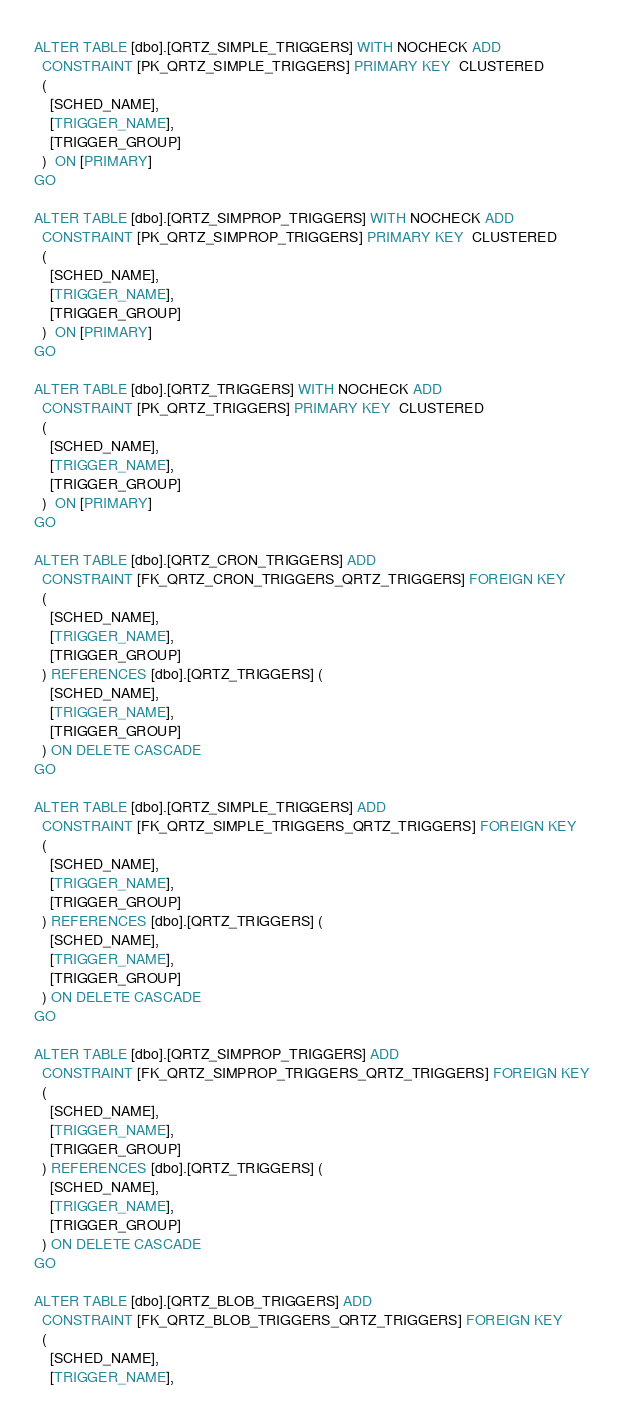Convert code to text. <code><loc_0><loc_0><loc_500><loc_500><_SQL_>
ALTER TABLE [dbo].[QRTZ_SIMPLE_TRIGGERS] WITH NOCHECK ADD
  CONSTRAINT [PK_QRTZ_SIMPLE_TRIGGERS] PRIMARY KEY  CLUSTERED
  (
    [SCHED_NAME],
    [TRIGGER_NAME],
    [TRIGGER_GROUP]
  )  ON [PRIMARY]
GO

ALTER TABLE [dbo].[QRTZ_SIMPROP_TRIGGERS] WITH NOCHECK ADD
  CONSTRAINT [PK_QRTZ_SIMPROP_TRIGGERS] PRIMARY KEY  CLUSTERED
  (
    [SCHED_NAME],
    [TRIGGER_NAME],
    [TRIGGER_GROUP]
  )  ON [PRIMARY]
GO

ALTER TABLE [dbo].[QRTZ_TRIGGERS] WITH NOCHECK ADD
  CONSTRAINT [PK_QRTZ_TRIGGERS] PRIMARY KEY  CLUSTERED
  (
    [SCHED_NAME],
    [TRIGGER_NAME],
    [TRIGGER_GROUP]
  )  ON [PRIMARY]
GO

ALTER TABLE [dbo].[QRTZ_CRON_TRIGGERS] ADD
  CONSTRAINT [FK_QRTZ_CRON_TRIGGERS_QRTZ_TRIGGERS] FOREIGN KEY
  (
    [SCHED_NAME],
    [TRIGGER_NAME],
    [TRIGGER_GROUP]
  ) REFERENCES [dbo].[QRTZ_TRIGGERS] (
    [SCHED_NAME],
    [TRIGGER_NAME],
    [TRIGGER_GROUP]
  ) ON DELETE CASCADE
GO

ALTER TABLE [dbo].[QRTZ_SIMPLE_TRIGGERS] ADD
  CONSTRAINT [FK_QRTZ_SIMPLE_TRIGGERS_QRTZ_TRIGGERS] FOREIGN KEY
  (
    [SCHED_NAME],
    [TRIGGER_NAME],
    [TRIGGER_GROUP]
  ) REFERENCES [dbo].[QRTZ_TRIGGERS] (
    [SCHED_NAME],
    [TRIGGER_NAME],
    [TRIGGER_GROUP]
  ) ON DELETE CASCADE
GO

ALTER TABLE [dbo].[QRTZ_SIMPROP_TRIGGERS] ADD
  CONSTRAINT [FK_QRTZ_SIMPROP_TRIGGERS_QRTZ_TRIGGERS] FOREIGN KEY
  (
    [SCHED_NAME],
    [TRIGGER_NAME],
    [TRIGGER_GROUP]
  ) REFERENCES [dbo].[QRTZ_TRIGGERS] (
    [SCHED_NAME],
    [TRIGGER_NAME],
    [TRIGGER_GROUP]
  ) ON DELETE CASCADE
GO

ALTER TABLE [dbo].[QRTZ_BLOB_TRIGGERS] ADD
  CONSTRAINT [FK_QRTZ_BLOB_TRIGGERS_QRTZ_TRIGGERS] FOREIGN KEY
  (
    [SCHED_NAME],
    [TRIGGER_NAME],</code> 